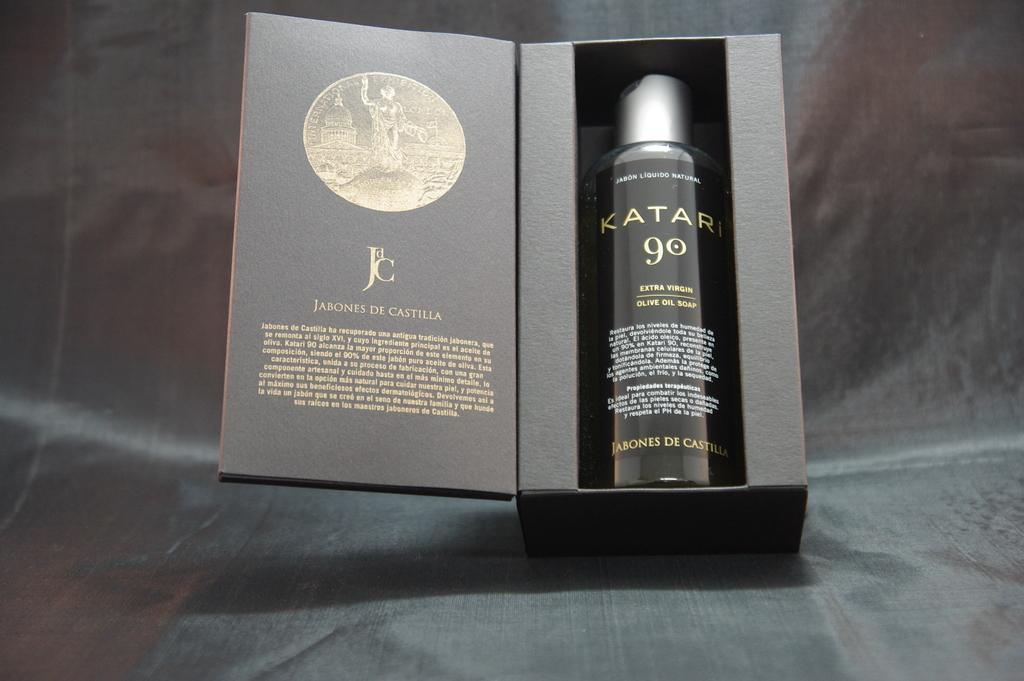Provide a one-sentence caption for the provided image. A box with a bottle of Katari 90 inside of ir. 